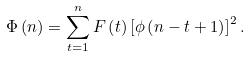<formula> <loc_0><loc_0><loc_500><loc_500>\Phi \left ( n \right ) = \sum _ { t = 1 } ^ { n } F \left ( t \right ) \left [ \phi \left ( n - t + 1 \right ) \right ] ^ { 2 } .</formula> 